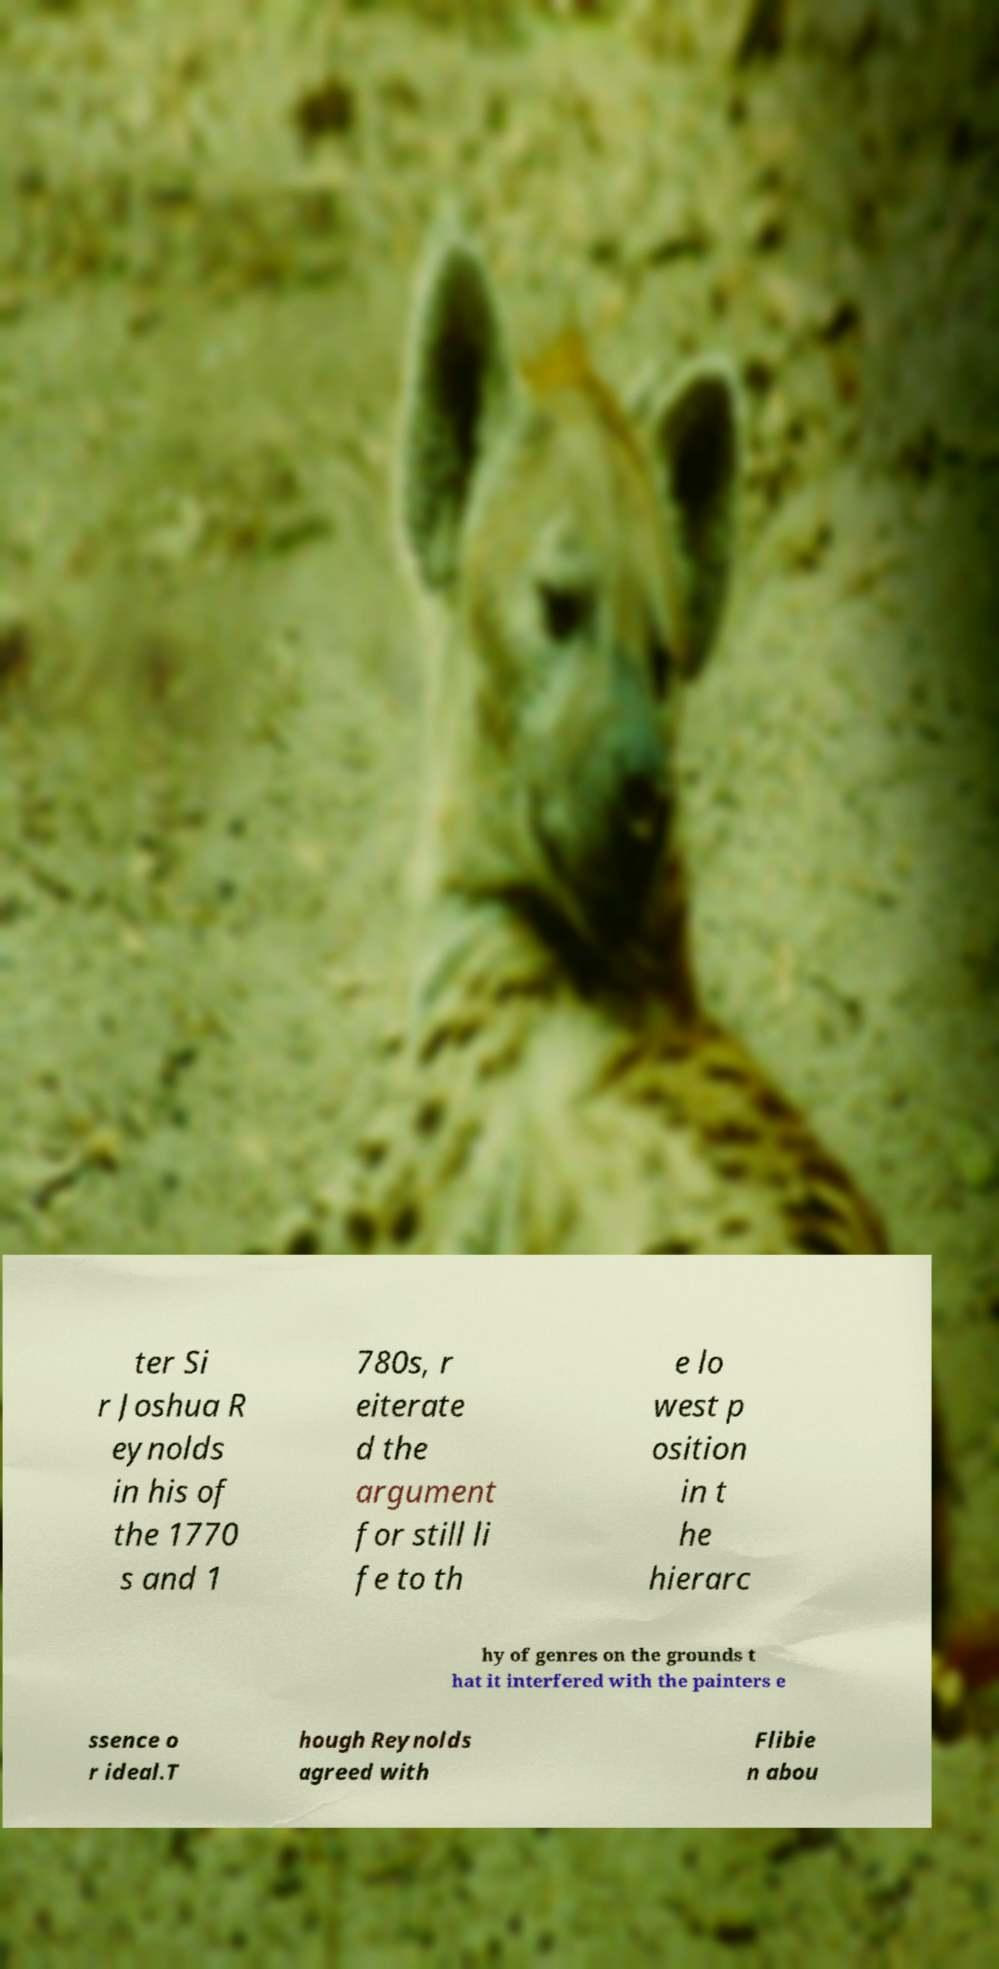Could you assist in decoding the text presented in this image and type it out clearly? ter Si r Joshua R eynolds in his of the 1770 s and 1 780s, r eiterate d the argument for still li fe to th e lo west p osition in t he hierarc hy of genres on the grounds t hat it interfered with the painters e ssence o r ideal.T hough Reynolds agreed with Flibie n abou 